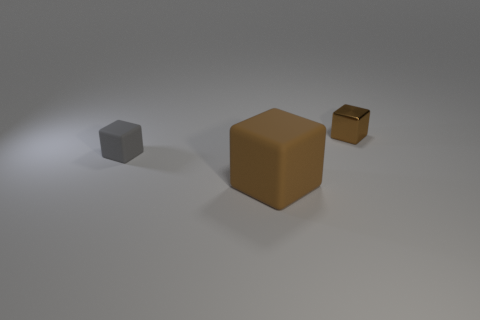Add 3 small metal blocks. How many objects exist? 6 Subtract 0 blue spheres. How many objects are left? 3 Subtract all cubes. Subtract all tiny metallic balls. How many objects are left? 0 Add 2 large brown objects. How many large brown objects are left? 3 Add 3 small gray blocks. How many small gray blocks exist? 4 